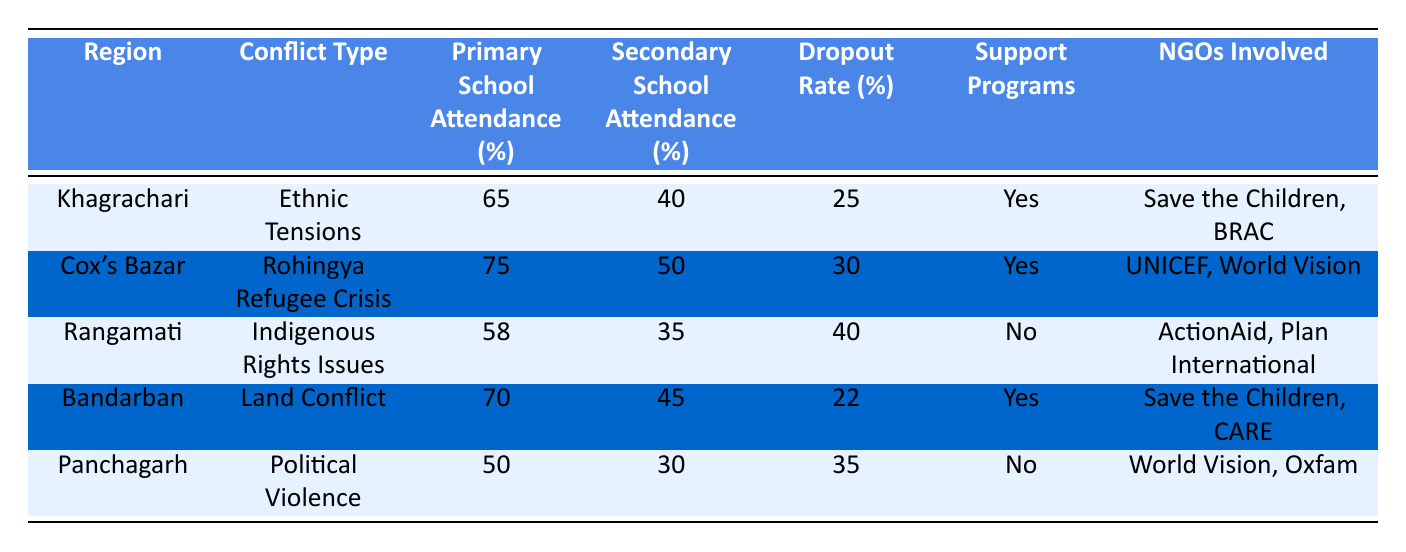What is the primary school attendance rate in Cox's Bazar? The table shows that the primary school attendance rate in Cox's Bazar is 75%.
Answer: 75% Which region has the highest secondary school attendance? By comparing the secondary school attendance rates in the table, Cox's Bazar has the highest rate at 50%.
Answer: 50% Is there a support program in Rangamati? The table indicates that Rangamati does not have a support program, as the "Support Programs" column shows "No."
Answer: No What is the dropout rate for children in Bandarban? The table lists the dropout rate in Bandarban as 22%.
Answer: 22% What is the average primary school attendance rate across all regions? To calculate the average, sum the primary school attendance rates: (65 + 75 + 58 + 70 + 50) = 318. There are 5 regions, so the average is 318/5 = 63.6%.
Answer: 63.6% Which region has the lowest percentage of secondary school attendance, and what is that percentage? By looking at the secondary school attendance data, Rangamati has the lowest percentage at 35%.
Answer: 35% How many regions have support programs in place? The table indicates that there are support programs in 3 regions (Khagrachari, Cox's Bazar, and Bandarban) by checking the "Support Programs" column.
Answer: 3 What is the difference in primary school attendance between Khagrachari and Panchagarh? The primary school attendance for Khagrachari is 65% and for Panchagarh is 50%. The difference is 65 - 50 = 15%.
Answer: 15% Does the region of Cox's Bazar have NGOs involved in educational support? Yes, the table shows that Cox's Bazar has NGOs involved, specifically UNICEF and World Vision, as indicated in the "NGOs Involved" column.
Answer: Yes 